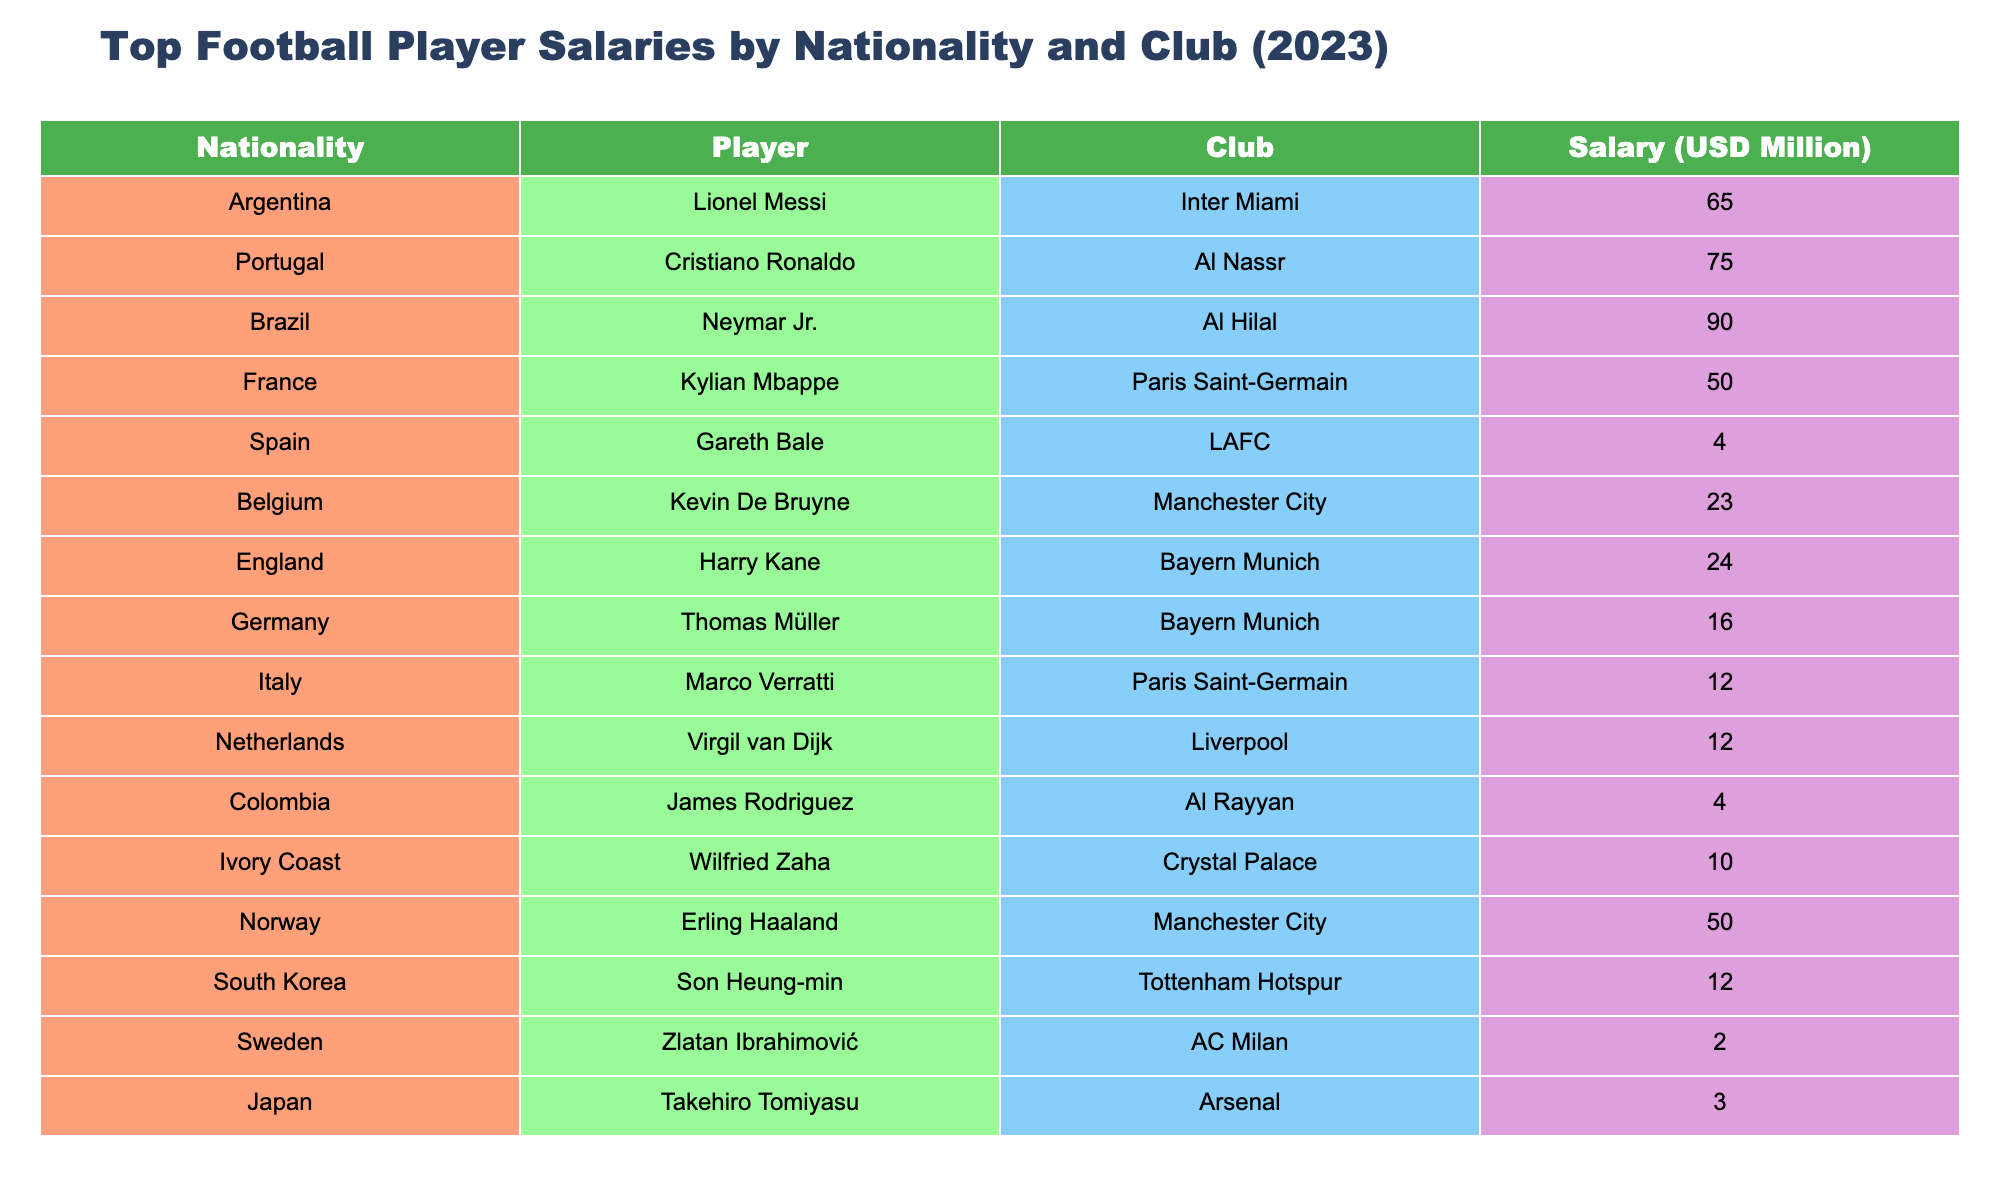What is the highest salary in the table? The highest salary is given for Neymar Jr. at Al Hilal, which is 90 million USD.
Answer: 90 million USD Which player from Brazil has the highest salary? Neymar Jr. is the only Brazilian listed, with a salary of 90 million USD.
Answer: Neymar Jr. at 90 million USD What is the combined salary of players from Bayern Munich? The total salary for players from Bayern Munich (Harry Kane and Thomas Müller) is 24 + 16 = 40 million USD.
Answer: 40 million USD Is Lionel Messi's salary higher than that of Kylian Mbappe? Lionel Messi earns 65 million USD while Kylian Mbappe earns 50 million USD, so Messi's salary is higher.
Answer: Yes Which nationality has the player with the lowest salary? Sweden has the player with the lowest salary, Zlatan Ibrahimović, earning 2 million USD.
Answer: Sweden What is the average salary of the players listed from Manchester City? Kevin De Bruyne and Erling Haaland are the two players from Manchester City, with 23 and 50 million USD, respectively. Their average salary is (23 + 50) / 2 = 36.5 million USD.
Answer: 36.5 million USD Are there more players from England or Italy and what are their salaries? There is one player from England (Harry Kane with 24 million USD) and one from Italy (Marco Verratti with 12 million USD). Their counts are equal, but Kane earns more.
Answer: Equal count; Kane is higher What is the total salary of players from Paris Saint-Germain? The total salary for players from Paris Saint-Germain (Kylian Mbappe and Marco Verratti) is 50 + 12 = 62 million USD.
Answer: 62 million USD Which player has a salary less than 10 million USD? Gareth Bale from Spain (4 million USD), James Rodriguez from Colombia (4 million USD), and Zlatan Ibrahimović from Sweden (2 million USD) all have salaries less than 10 million USD.
Answer: Three players Compare the salaries of Son Heung-min and Wilfried Zaha. Who earns more? Son Heung-min has a salary of 12 million USD, while Wilfried Zaha earns 10 million USD. Therefore, Son Heung-min earns more.
Answer: Son Heung-min What percentage of the total salary does Cristiano Ronaldo earn compared to the total from the table? The total salaries of all players in the table sum to 454 million USD. Cristiano Ronaldo’s salary of 75 million USD compares as (75 / 454) * 100 = 16.54%.
Answer: 16.54% 